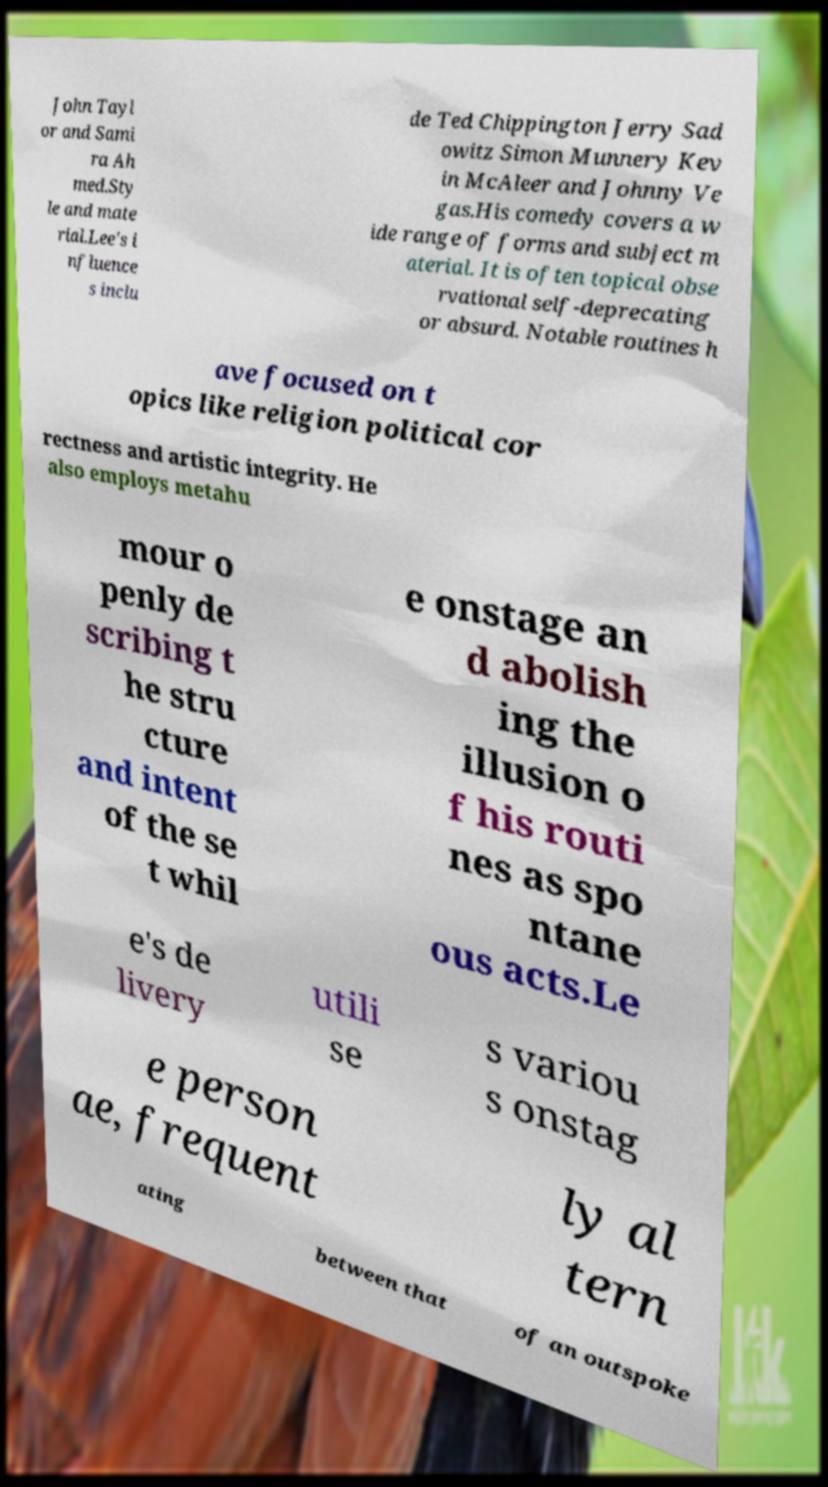Please read and relay the text visible in this image. What does it say? John Tayl or and Sami ra Ah med.Sty le and mate rial.Lee's i nfluence s inclu de Ted Chippington Jerry Sad owitz Simon Munnery Kev in McAleer and Johnny Ve gas.His comedy covers a w ide range of forms and subject m aterial. It is often topical obse rvational self-deprecating or absurd. Notable routines h ave focused on t opics like religion political cor rectness and artistic integrity. He also employs metahu mour o penly de scribing t he stru cture and intent of the se t whil e onstage an d abolish ing the illusion o f his routi nes as spo ntane ous acts.Le e's de livery utili se s variou s onstag e person ae, frequent ly al tern ating between that of an outspoke 